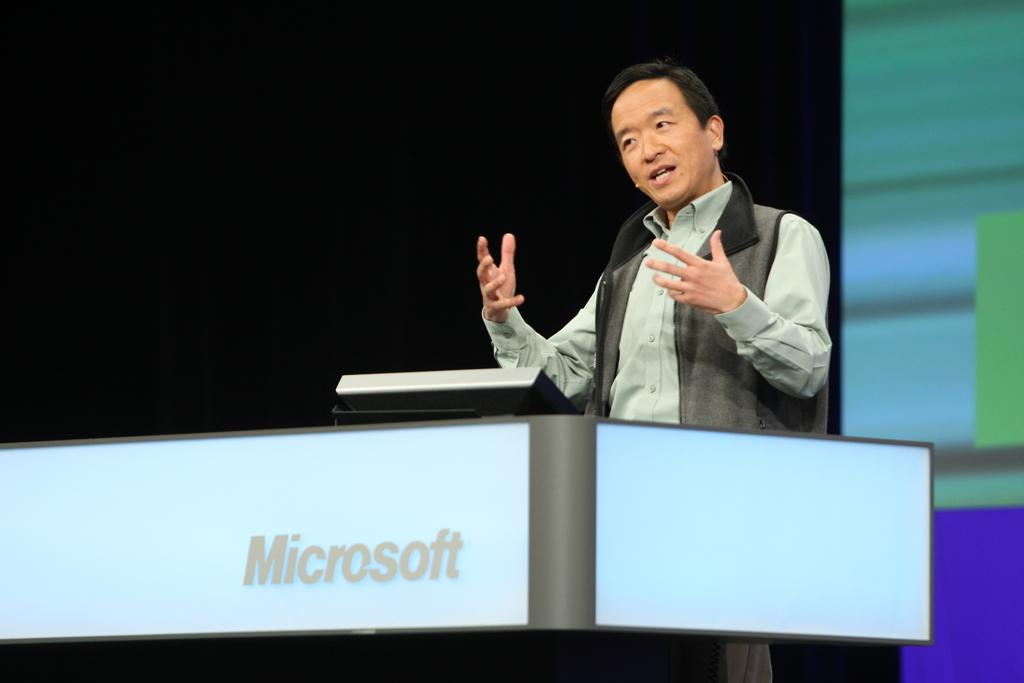What is the man in the image doing near the podium? The man is standing near a podium in the image. What can be seen on the screen in the image? Unfortunately, the facts provided do not give any information about the content of the screen. How would you describe the lighting in the image? The background of the image is dark. What type of seed is being planted in the image? There is no seed or planting activity present in the image. How does the man's rhythm affect the audience's reaction in the image? There is no information about the man's rhythm or the audience's reaction in the image. 